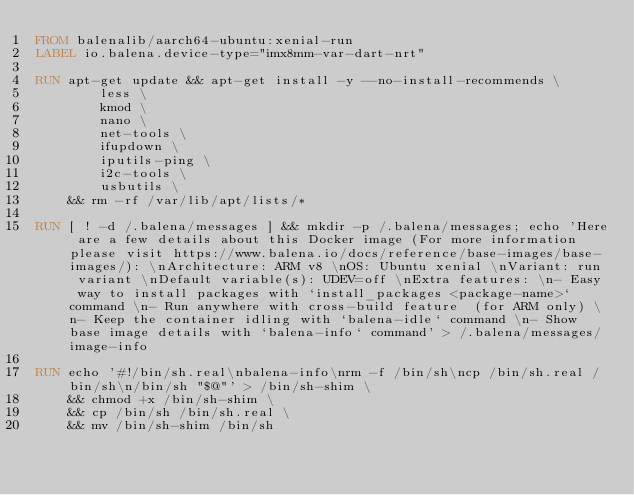<code> <loc_0><loc_0><loc_500><loc_500><_Dockerfile_>FROM balenalib/aarch64-ubuntu:xenial-run
LABEL io.balena.device-type="imx8mm-var-dart-nrt"

RUN apt-get update && apt-get install -y --no-install-recommends \
		less \
		kmod \
		nano \
		net-tools \
		ifupdown \
		iputils-ping \
		i2c-tools \
		usbutils \
	&& rm -rf /var/lib/apt/lists/*

RUN [ ! -d /.balena/messages ] && mkdir -p /.balena/messages; echo 'Here are a few details about this Docker image (For more information please visit https://www.balena.io/docs/reference/base-images/base-images/): \nArchitecture: ARM v8 \nOS: Ubuntu xenial \nVariant: run variant \nDefault variable(s): UDEV=off \nExtra features: \n- Easy way to install packages with `install_packages <package-name>` command \n- Run anywhere with cross-build feature  (for ARM only) \n- Keep the container idling with `balena-idle` command \n- Show base image details with `balena-info` command' > /.balena/messages/image-info

RUN echo '#!/bin/sh.real\nbalena-info\nrm -f /bin/sh\ncp /bin/sh.real /bin/sh\n/bin/sh "$@"' > /bin/sh-shim \
	&& chmod +x /bin/sh-shim \
	&& cp /bin/sh /bin/sh.real \
	&& mv /bin/sh-shim /bin/sh</code> 